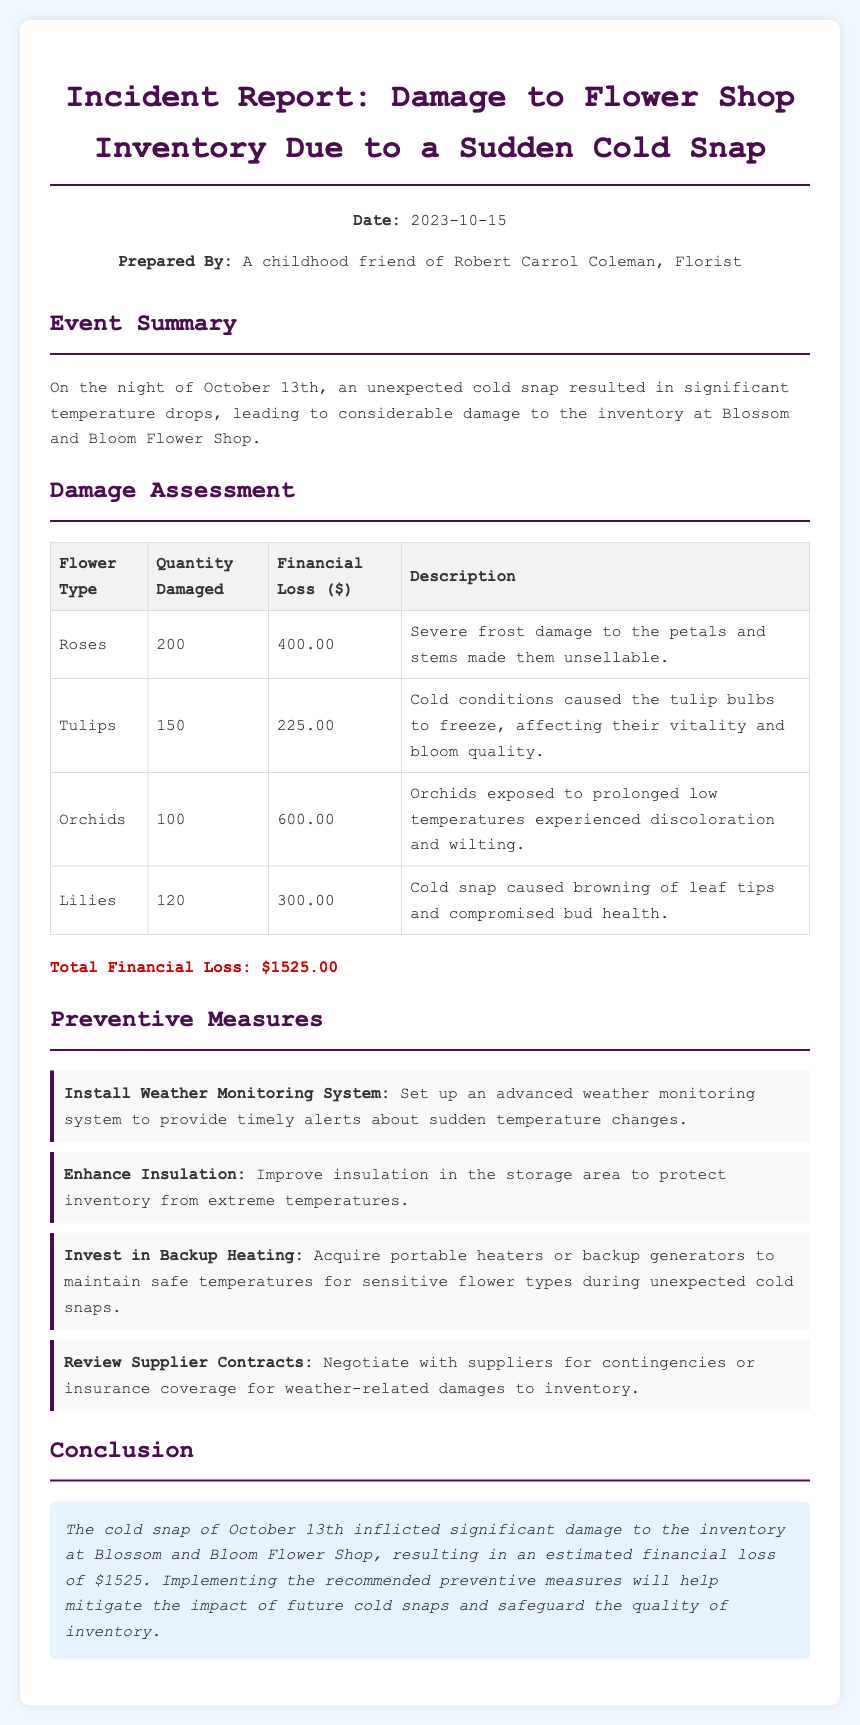What date did the cold snap occur? The cold snap occurred on the night of October 13th, as stated in the report.
Answer: October 13th What is the total financial loss reported? The total financial loss is indicated at the end of the Damage Assessment section.
Answer: $1525.00 How many orchids were damaged? The document specifies the quantity of damaged orchids in the Damage Assessment table.
Answer: 100 What was the financial loss for the roses? The document lists the financial loss specifically associated with roses in the Damage Assessment table.
Answer: $400.00 What measure involves setting up a weather monitoring system? The preventive measure recommending a weather monitoring system is detailed in the Preventive Measures section.
Answer: Install Weather Monitoring System Which type of flower experienced discoloration and wilting? The report states that orchids experienced discoloration and wilting due to exposure to low temperatures.
Answer: Orchids What required improvement to help protect inventory? The document mentions improving insulation as a preventive measure against extreme temperatures.
Answer: Insulation How many total types of flowers were listed in the damage assessment? The Damage Assessment section details four types of flowers that sustained damage.
Answer: Four What is the first preventative measure recommended? The document lists preventive measures, and the first one is mentioned in sequence.
Answer: Install Weather Monitoring System 